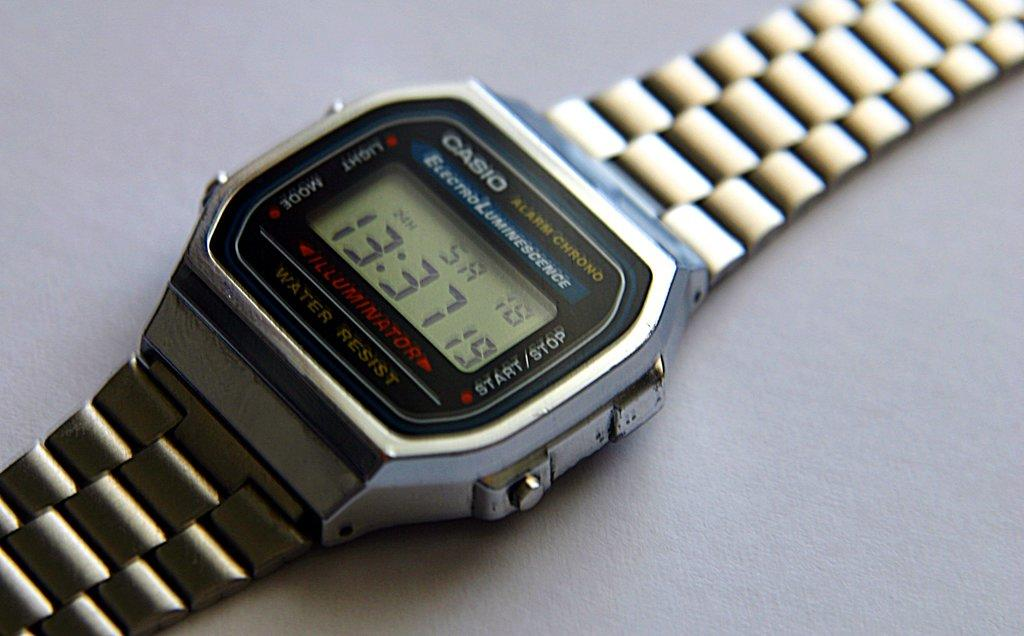<image>
Render a clear and concise summary of the photo. A silver casio wrist watch showing 13:37 19. 